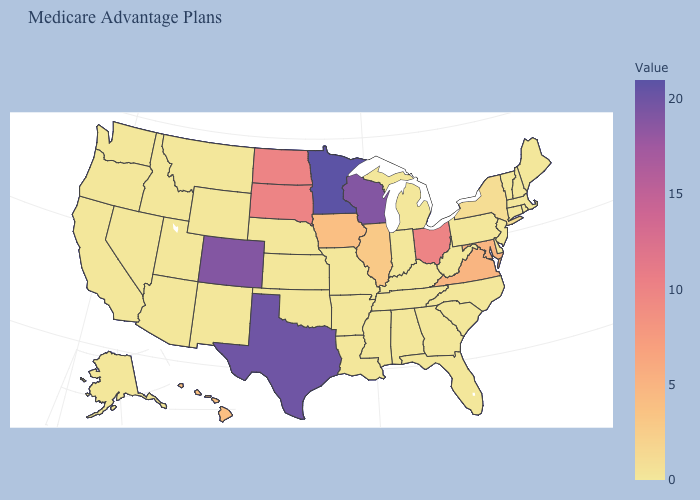Which states hav the highest value in the Northeast?
Short answer required. New York. Which states have the lowest value in the MidWest?
Keep it brief. Indiana, Kansas, Michigan, Missouri, Nebraska. 